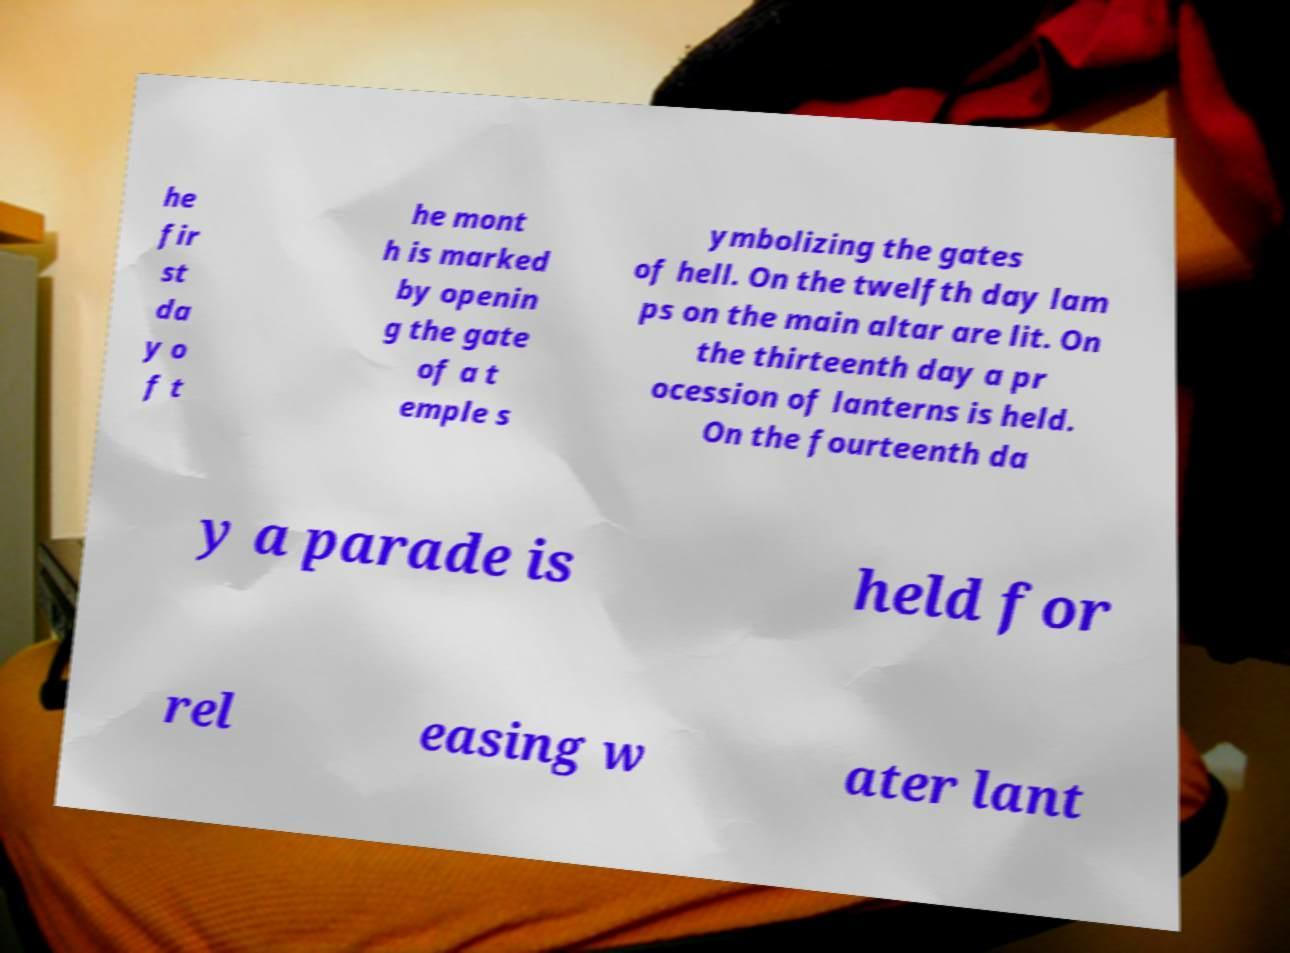Can you accurately transcribe the text from the provided image for me? he fir st da y o f t he mont h is marked by openin g the gate of a t emple s ymbolizing the gates of hell. On the twelfth day lam ps on the main altar are lit. On the thirteenth day a pr ocession of lanterns is held. On the fourteenth da y a parade is held for rel easing w ater lant 